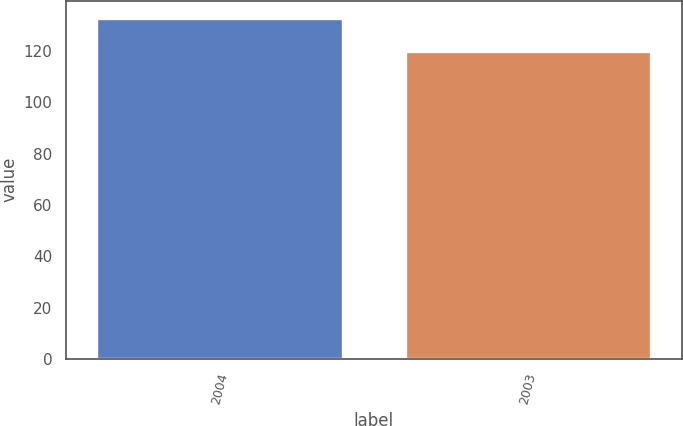<chart> <loc_0><loc_0><loc_500><loc_500><bar_chart><fcel>2004<fcel>2003<nl><fcel>133<fcel>120<nl></chart> 